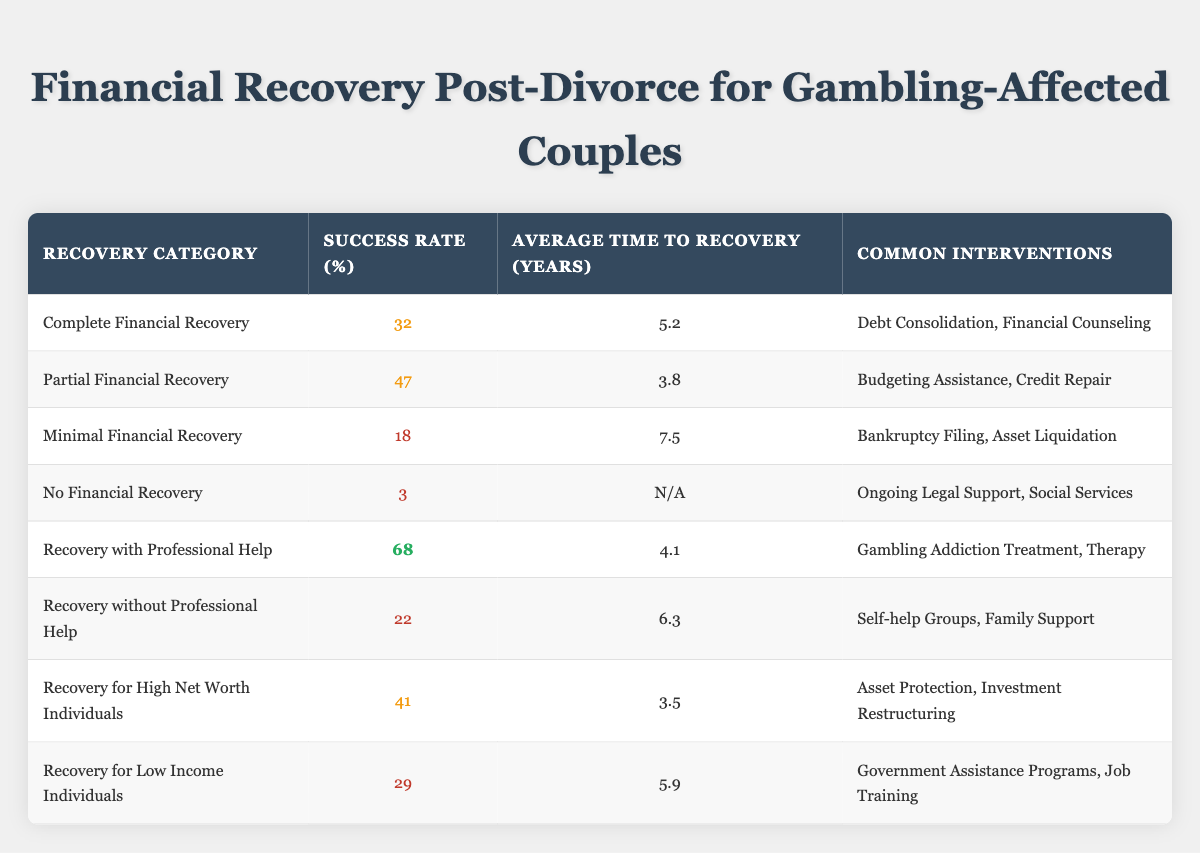What is the success rate for complete financial recovery? The table shows a success rate of 32% for complete financial recovery.
Answer: 32% What is the average time to recovery for minimal financial recovery? The table indicates that the average time to recovery for minimal financial recovery is 7.5 years.
Answer: 7.5 years Which recovery category has the highest success rate? Recovery with professional help has the highest success rate of 68%.
Answer: 68% Is the success rate for recovery without professional help higher than for recovery for low-income individuals? The success rate for recovery without professional help is 22%, while for low-income individuals, it is 29%. Therefore, 22% is not higher than 29%.
Answer: No What is the difference in success rates between partial financial recovery and recovery for high net worth individuals? Partial financial recovery has a success rate of 47%, while recovery for high net worth individuals is 41%. The difference is 47% - 41% = 6%.
Answer: 6% What is the average success rate for recovery categories that involve professional help? There are two categories involving professional help: recovery with professional help (68%) and no financial recovery (3%). The average is (68% + 3%) / 2 = 35.5%.
Answer: 35.5% How many recovery categories have a success rate lower than 30%? There are two categories with a success rate lower than 30%: minimal financial recovery (18%) and no financial recovery (3%). Therefore, the total is 2.
Answer: 2 Does minimal financial recovery take longer on average than recovery for high net worth individuals? Minimal financial recovery takes 7.5 years, while recovery for high net worth individuals takes 3.5 years. Since 7.5 years is greater than 3.5 years, the answer is yes.
Answer: Yes Which common intervention is associated with the recovery category that has the second lowest success rate? The second lowest success rate is for minimal financial recovery at 18%, and the common interventions listed are bankruptcy filing and asset liquidation.
Answer: Bankruptcy Filing, Asset Liquidation 